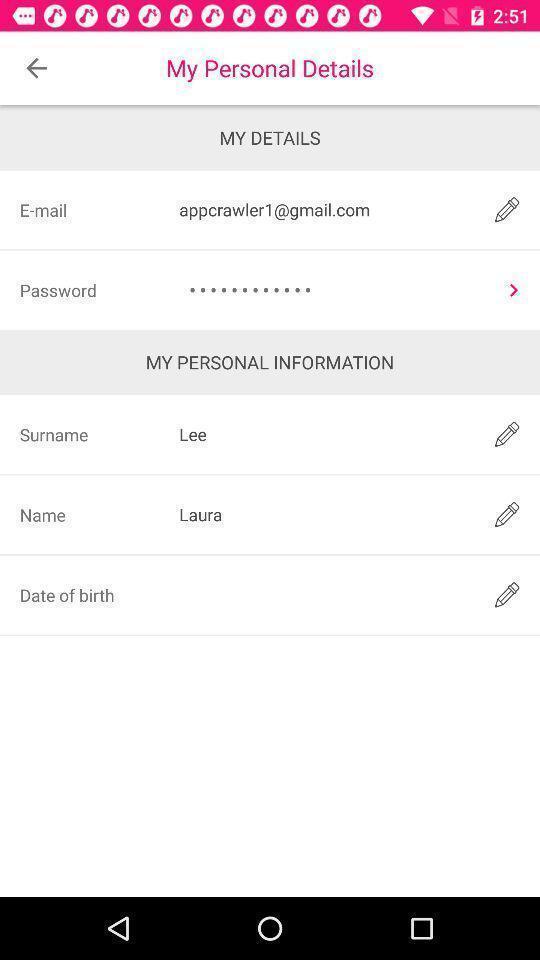What details can you identify in this image? Screen displaying my personal details page. 